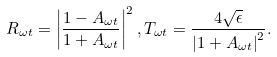Convert formula to latex. <formula><loc_0><loc_0><loc_500><loc_500>R _ { \omega t } = \left | \frac { 1 - A _ { \omega t } } { 1 + A _ { \omega t } } \right | ^ { 2 } , T _ { \omega t } = \frac { 4 \sqrt { \epsilon } } { \left | 1 + A _ { \omega t } \right | ^ { 2 } } .</formula> 